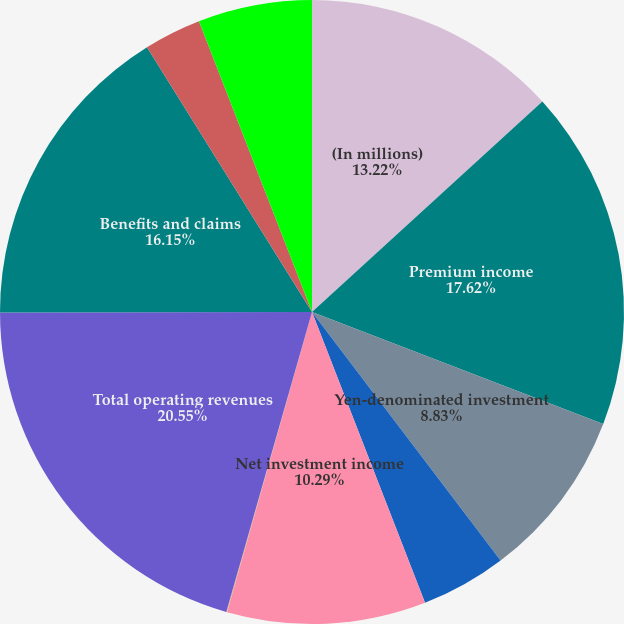Convert chart to OTSL. <chart><loc_0><loc_0><loc_500><loc_500><pie_chart><fcel>(In millions)<fcel>Premium income<fcel>Yen-denominated investment<fcel>Dollar-denominated investment<fcel>Net investment income<fcel>Other income<fcel>Total operating revenues<fcel>Benefits and claims<fcel>Amortization of deferred<fcel>Insurance commissions<nl><fcel>13.22%<fcel>17.62%<fcel>8.83%<fcel>4.43%<fcel>10.29%<fcel>0.04%<fcel>20.55%<fcel>16.15%<fcel>2.97%<fcel>5.9%<nl></chart> 